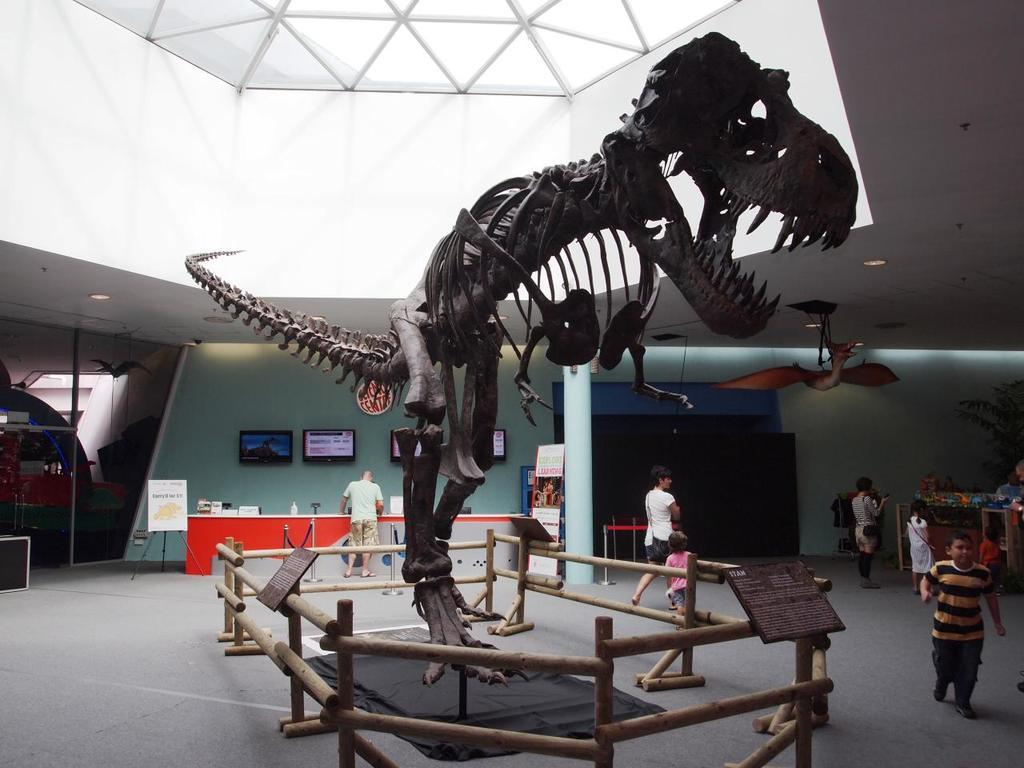What is the main subject in the center of the image? There is a depiction of a dinosaur in the center of the image. What are the people in the image doing? The people in the image are walking. What can be seen in the background of the image? There is a wall in the background of the image. What is on the wall in the background? There are TVs on the wall in the background. What type of glass can be seen on the table in the image? There is no table or glass present in the image. What is the people having for breakfast in the image? There is no reference to breakfast or people eating in the image. 